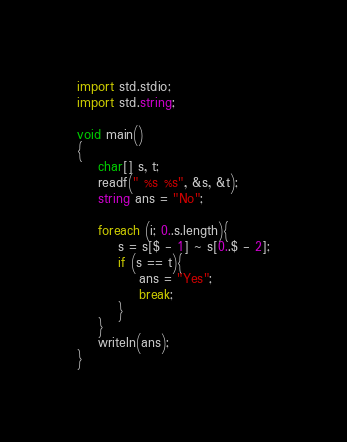<code> <loc_0><loc_0><loc_500><loc_500><_D_>import std.stdio;
import std.string;

void main()
{
    char[] s, t;
    readf(" %s %s", &s, &t);
    string ans = "No";

    foreach (i; 0..s.length){
        s = s[$ - 1] ~ s[0..$ - 2];
        if (s == t){
            ans = "Yes";
            break;
        }
    }
    writeln(ans);
}
</code> 